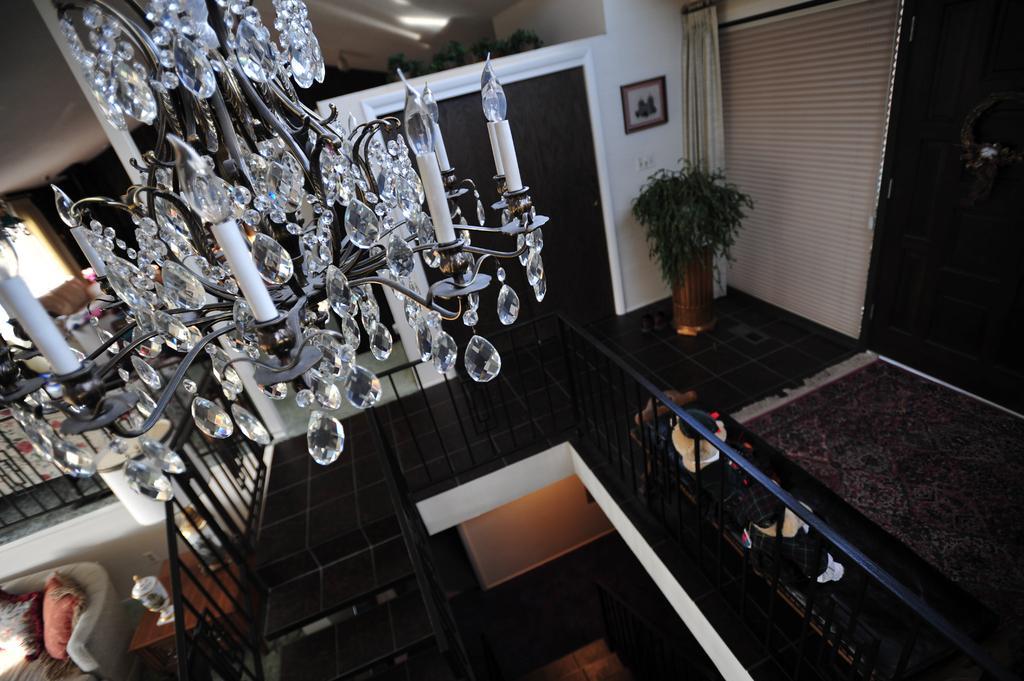Could you give a brief overview of what you see in this image? In the front of the image I can see chandelier. In the background of the image there are railings, window, curtain, plant, steps, toys, carpets, couches, pillows, table, door and objects. Above the table there are things. Picture is on the wall. Beside that picture there is a curtain. 